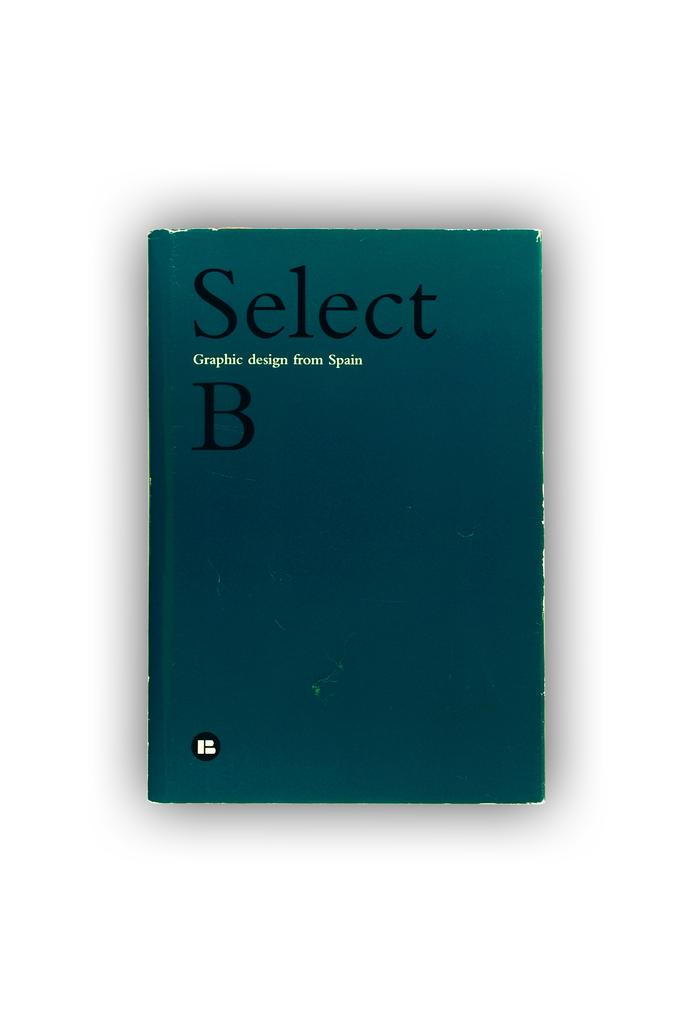<image>
Summarize the visual content of the image. A teal colored book sitting on a white surface with the title Select B. 